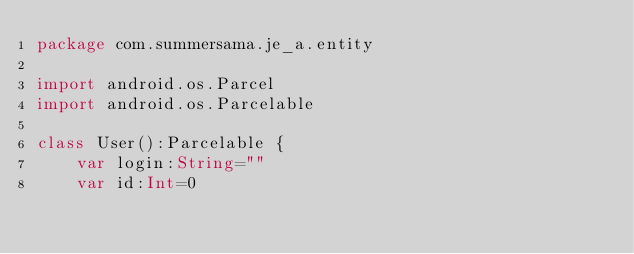<code> <loc_0><loc_0><loc_500><loc_500><_Kotlin_>package com.summersama.je_a.entity

import android.os.Parcel
import android.os.Parcelable

class User():Parcelable {
    var login:String=""
    var id:Int=0</code> 